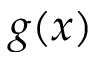<formula> <loc_0><loc_0><loc_500><loc_500>g ( x )</formula> 